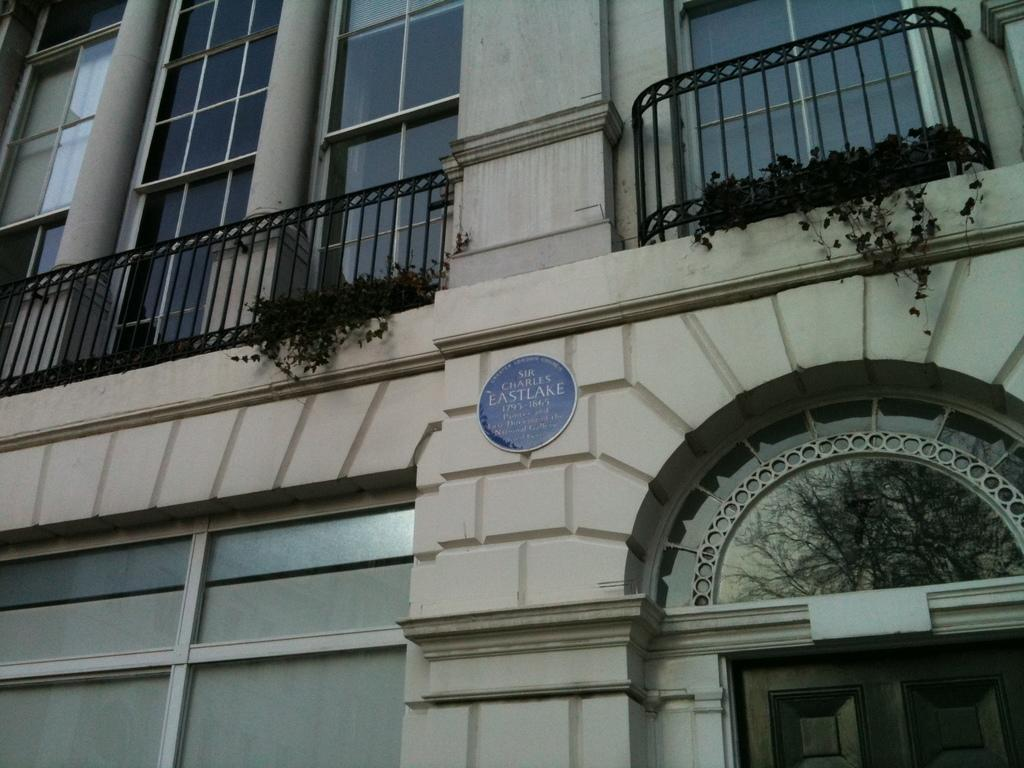What type of structure is visible in the image? There is a building in the image. What architectural features can be seen in the image? There are walls, pillars, and railings visible in the image. What objects are made of glass in the image? There are glass objects in the image. What is used for displaying information in the image? There is a board in the image for displaying information. What can be used for entering or exiting the building in the image? There is a door in the image for entering or exiting the building. What type of vegetation is present in the image? There are plants in the image. What type of juice is being served in the image? There is no juice present in the image. What is the building in the image trying to get the attention of passersby? The building in the image is not trying to get anyone's attention, as it is an inanimate object. 